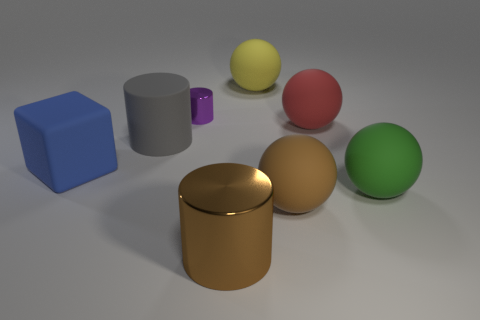How big is the purple object?
Keep it short and to the point. Small. How many small objects are the same color as the tiny shiny cylinder?
Ensure brevity in your answer.  0. Is the number of small purple metallic cylinders greater than the number of big purple rubber cylinders?
Your answer should be very brief. Yes. What size is the sphere that is in front of the big gray cylinder and behind the brown rubber object?
Your response must be concise. Large. Does the cylinder to the left of the purple shiny cylinder have the same material as the cylinder that is in front of the blue cube?
Make the answer very short. No. What is the shape of the green rubber thing that is the same size as the yellow thing?
Make the answer very short. Sphere. Are there fewer big green objects than brown objects?
Make the answer very short. Yes. There is a big matte thing behind the tiny object; is there a big cube behind it?
Offer a terse response. No. There is a brown thing on the left side of the sphere that is behind the tiny purple cylinder; are there any large gray cylinders that are right of it?
Provide a short and direct response. No. Does the matte thing that is in front of the large green sphere have the same shape as the large rubber object that is left of the rubber cylinder?
Offer a terse response. No. 